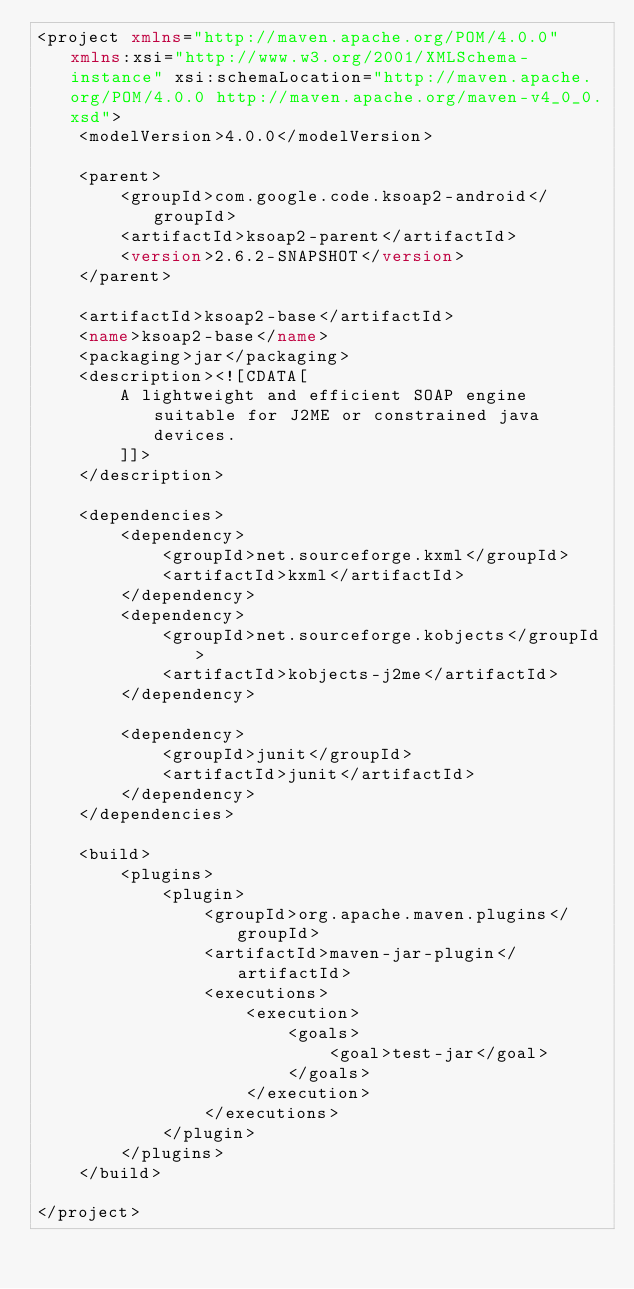<code> <loc_0><loc_0><loc_500><loc_500><_XML_><project xmlns="http://maven.apache.org/POM/4.0.0" xmlns:xsi="http://www.w3.org/2001/XMLSchema-instance" xsi:schemaLocation="http://maven.apache.org/POM/4.0.0 http://maven.apache.org/maven-v4_0_0.xsd">
	<modelVersion>4.0.0</modelVersion>
	
	<parent>
		<groupId>com.google.code.ksoap2-android</groupId>
		<artifactId>ksoap2-parent</artifactId>
		<version>2.6.2-SNAPSHOT</version>
	</parent>

	<artifactId>ksoap2-base</artifactId>
	<name>ksoap2-base</name>
	<packaging>jar</packaging>
	<description><![CDATA[
		A lightweight and efficient SOAP engine suitable for J2ME or constrained java devices.
		]]>
	</description>

	<dependencies>
		<dependency>
			<groupId>net.sourceforge.kxml</groupId>
			<artifactId>kxml</artifactId>
		</dependency>
		<dependency>
			<groupId>net.sourceforge.kobjects</groupId>
			<artifactId>kobjects-j2me</artifactId>
		</dependency>
		
		<dependency>
			<groupId>junit</groupId>
			<artifactId>junit</artifactId>
		</dependency>
	</dependencies>
	
	<build>
		<plugins>
			<plugin>
				<groupId>org.apache.maven.plugins</groupId>
				<artifactId>maven-jar-plugin</artifactId>
				<executions>
					<execution>
						<goals>
							<goal>test-jar</goal>
						</goals>
					</execution>
				</executions>
			</plugin>
		</plugins>
	</build>

</project>
</code> 